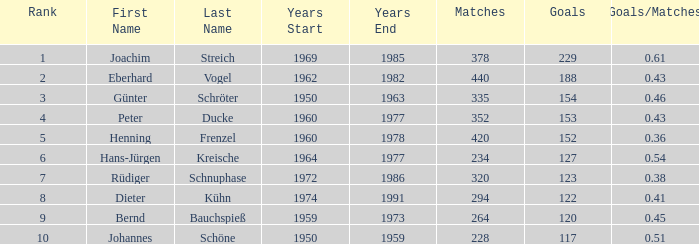For joachim streich as the name and over 378 matches, what is the least goal amount with a goals/matches ratio above 0.43? None. 